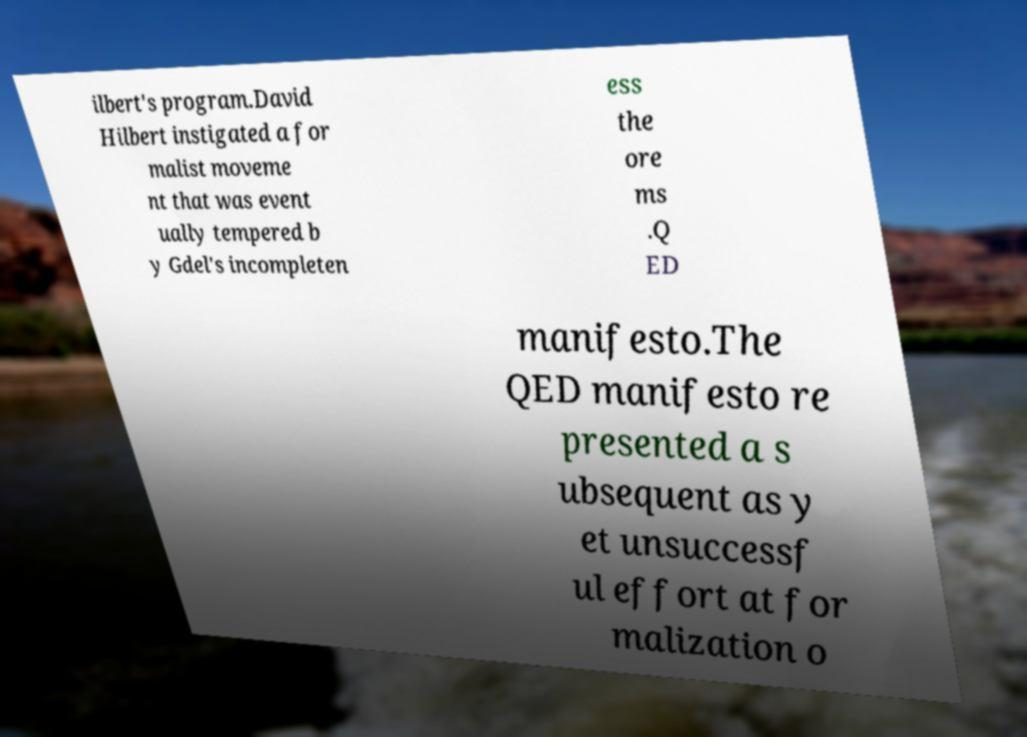I need the written content from this picture converted into text. Can you do that? ilbert's program.David Hilbert instigated a for malist moveme nt that was event ually tempered b y Gdel's incompleten ess the ore ms .Q ED manifesto.The QED manifesto re presented a s ubsequent as y et unsuccessf ul effort at for malization o 